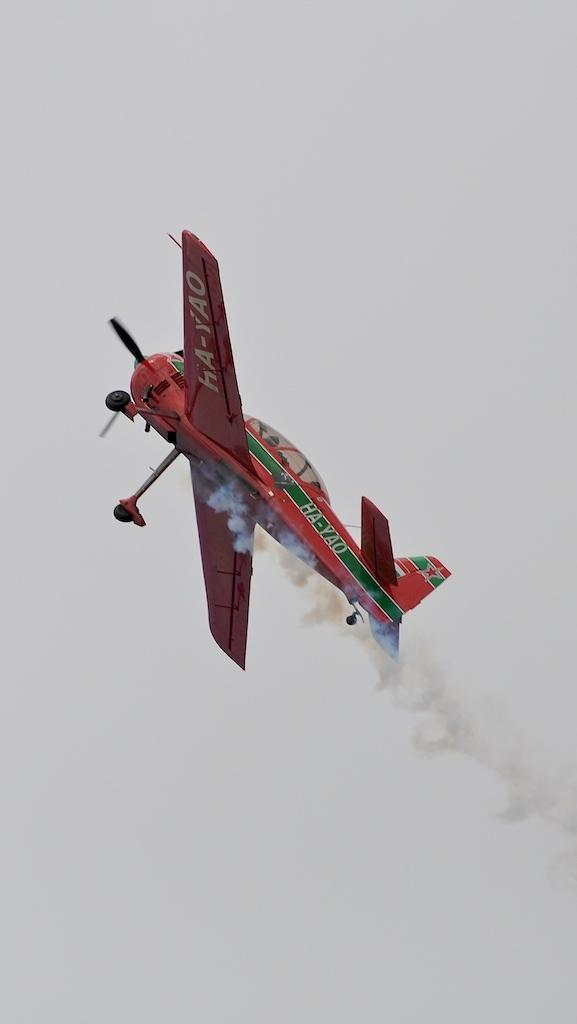What is the main subject of the picture? The main subject of the picture is a jet. What can be seen in the background of the picture? The sky is visible in the background of the picture. Where is the faucet located in the image? There is no faucet present in the image. What type of bead is hanging from the jet in the image? There is no bead present in the image. 